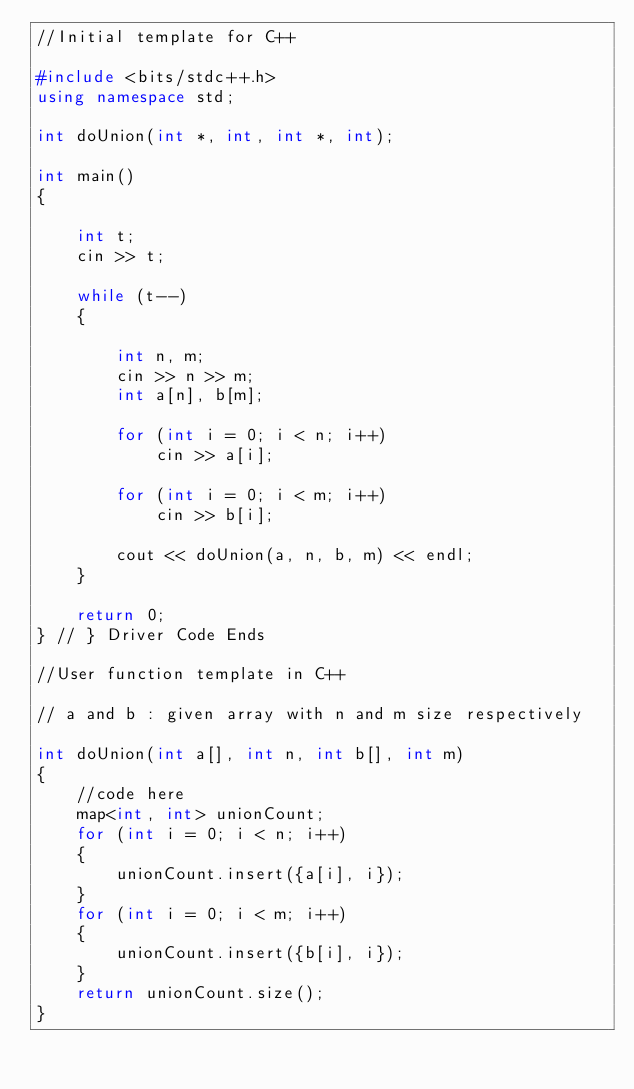Convert code to text. <code><loc_0><loc_0><loc_500><loc_500><_C++_>//Initial template for C++

#include <bits/stdc++.h>
using namespace std;

int doUnion(int *, int, int *, int);

int main()
{

    int t;
    cin >> t;

    while (t--)
    {

        int n, m;
        cin >> n >> m;
        int a[n], b[m];

        for (int i = 0; i < n; i++)
            cin >> a[i];

        for (int i = 0; i < m; i++)
            cin >> b[i];

        cout << doUnion(a, n, b, m) << endl;
    }

    return 0;
} // } Driver Code Ends

//User function template in C++

// a and b : given array with n and m size respectively

int doUnion(int a[], int n, int b[], int m)
{
    //code here
    map<int, int> unionCount;
    for (int i = 0; i < n; i++)
    {
        unionCount.insert({a[i], i});
    }
    for (int i = 0; i < m; i++)
    {
        unionCount.insert({b[i], i});
    }
    return unionCount.size();
}</code> 